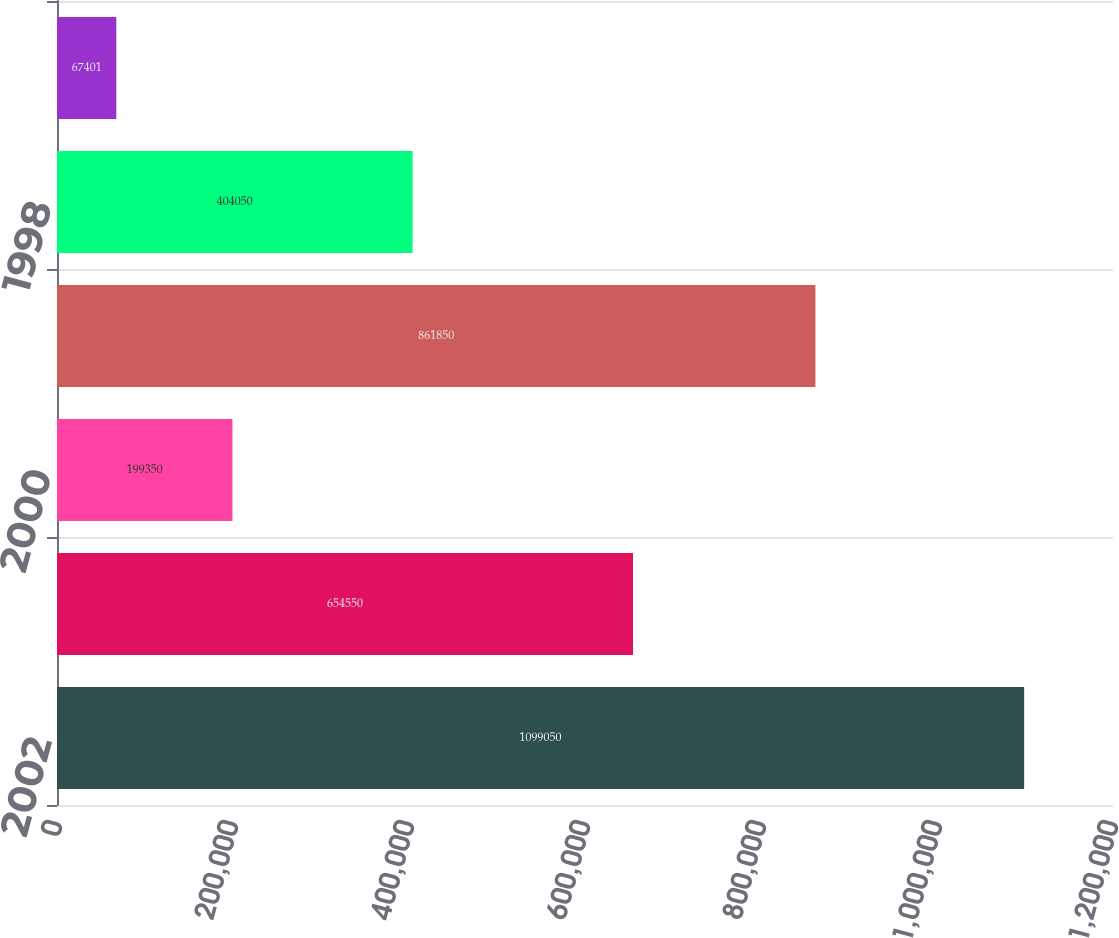Convert chart to OTSL. <chart><loc_0><loc_0><loc_500><loc_500><bar_chart><fcel>2002<fcel>2001<fcel>2000<fcel>1999<fcel>1998<fcel>1997/96<nl><fcel>1.09905e+06<fcel>654550<fcel>199350<fcel>861850<fcel>404050<fcel>67401<nl></chart> 